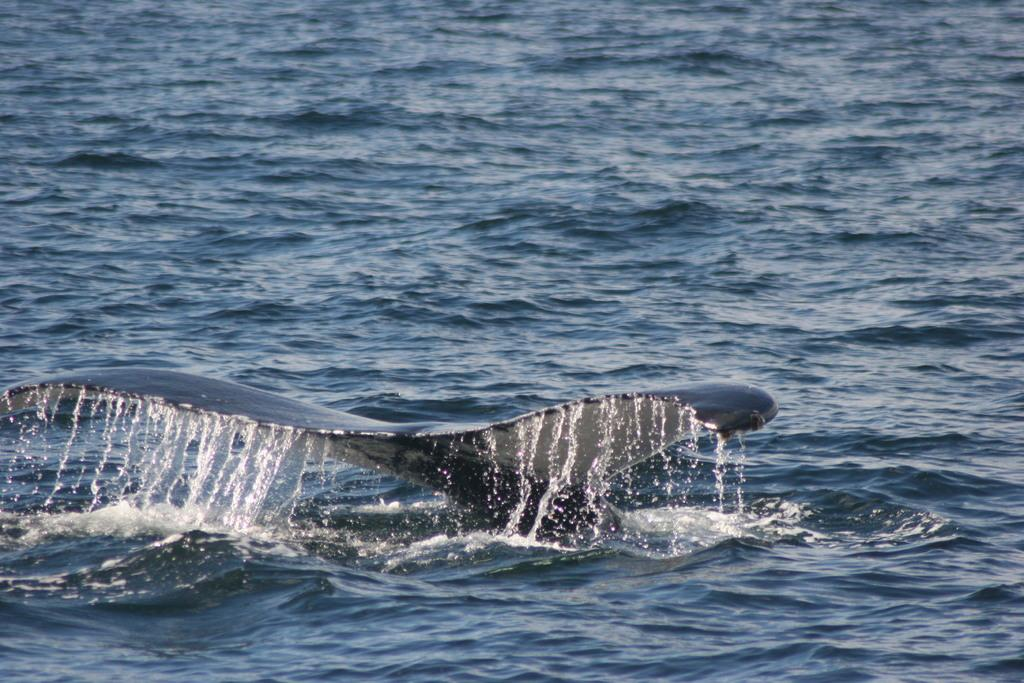What is the main subject of the image? The main subject of the image is a whale tail in the water. Can you describe the location of the whale tail? The whale tail is in the water in the image. What type of coal is being used by the women in the image? There are no women or coal present in the image; it features a whale tail in the water. 